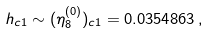<formula> <loc_0><loc_0><loc_500><loc_500>h _ { c 1 } \sim ( \eta _ { 8 } ^ { ( 0 ) } ) _ { c 1 } = 0 . 0 3 5 4 8 6 3 \, ,</formula> 